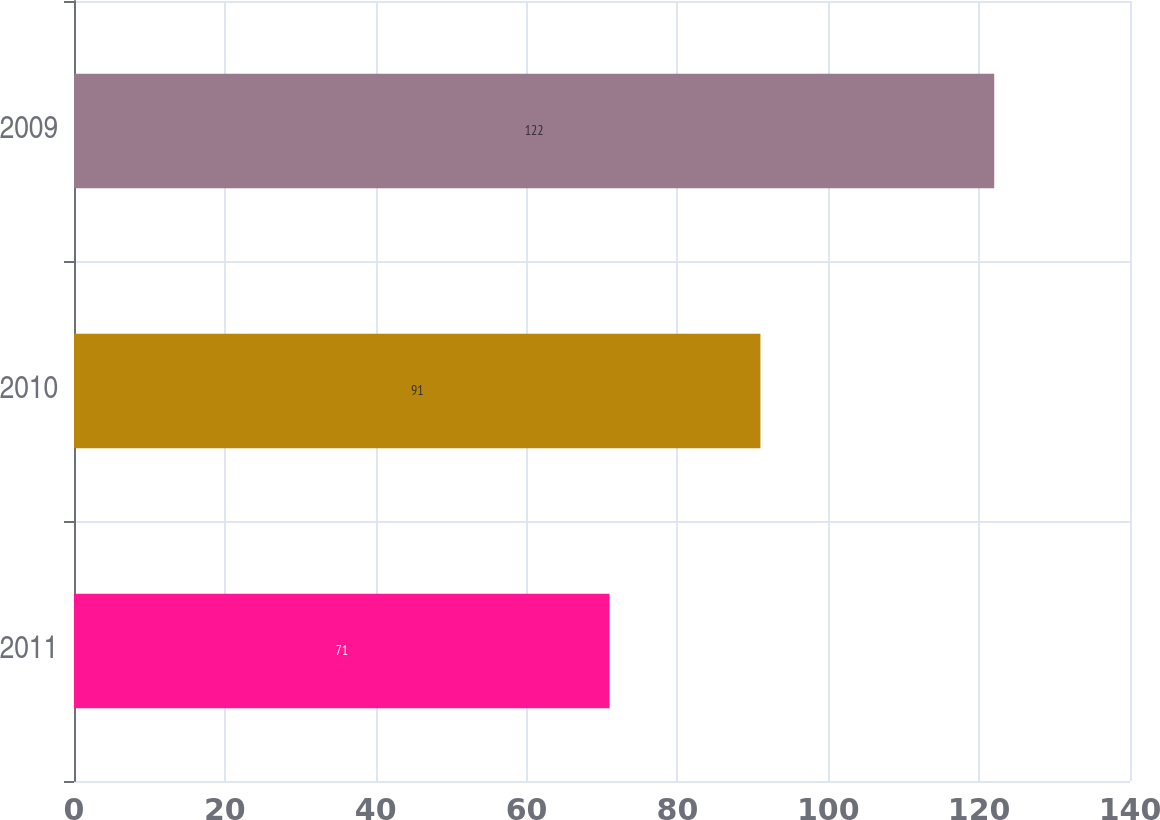Convert chart. <chart><loc_0><loc_0><loc_500><loc_500><bar_chart><fcel>2011<fcel>2010<fcel>2009<nl><fcel>71<fcel>91<fcel>122<nl></chart> 